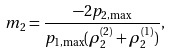<formula> <loc_0><loc_0><loc_500><loc_500>m _ { 2 } = \frac { - 2 p _ { 2 , \max } } { p _ { 1 , \max } ( \rho _ { 2 } ^ { ( 2 ) } + \rho _ { 2 } ^ { ( 1 ) } ) } ,</formula> 